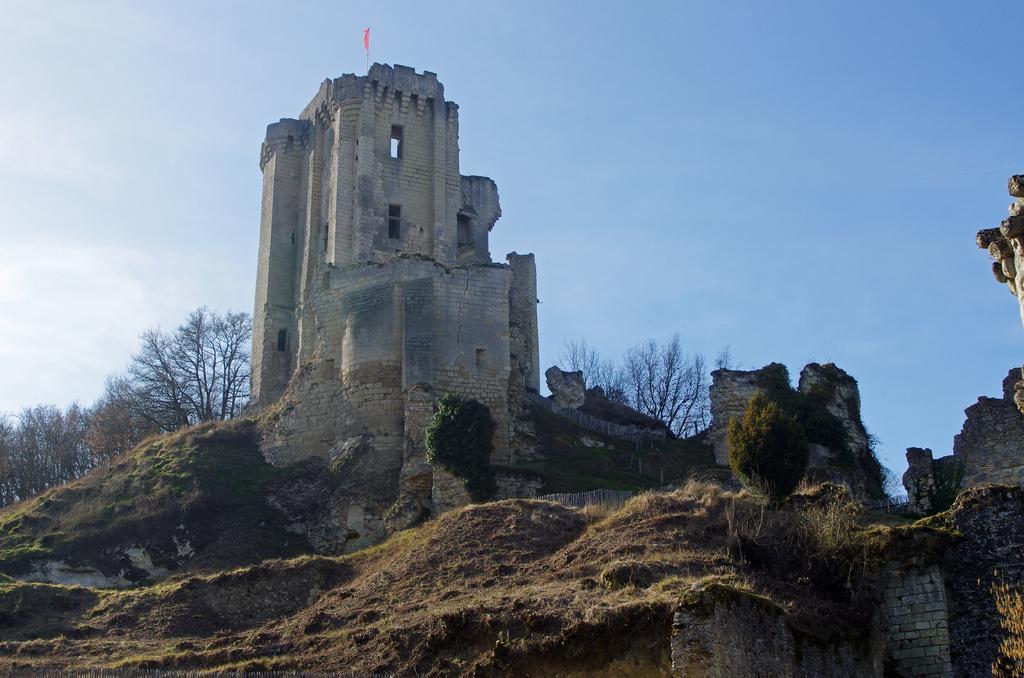In one or two sentences, can you explain what this image depicts? In this image, we can see some fort. Background there are so many trees. Here we can see some plants, wall. Top of the image, there is a flag with pole and sky. 